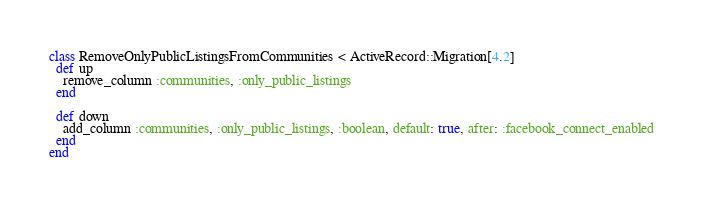<code> <loc_0><loc_0><loc_500><loc_500><_Ruby_>class RemoveOnlyPublicListingsFromCommunities < ActiveRecord::Migration[4.2]
  def up
    remove_column :communities, :only_public_listings
  end

  def down
    add_column :communities, :only_public_listings, :boolean, default: true, after: :facebook_connect_enabled
  end
end
</code> 